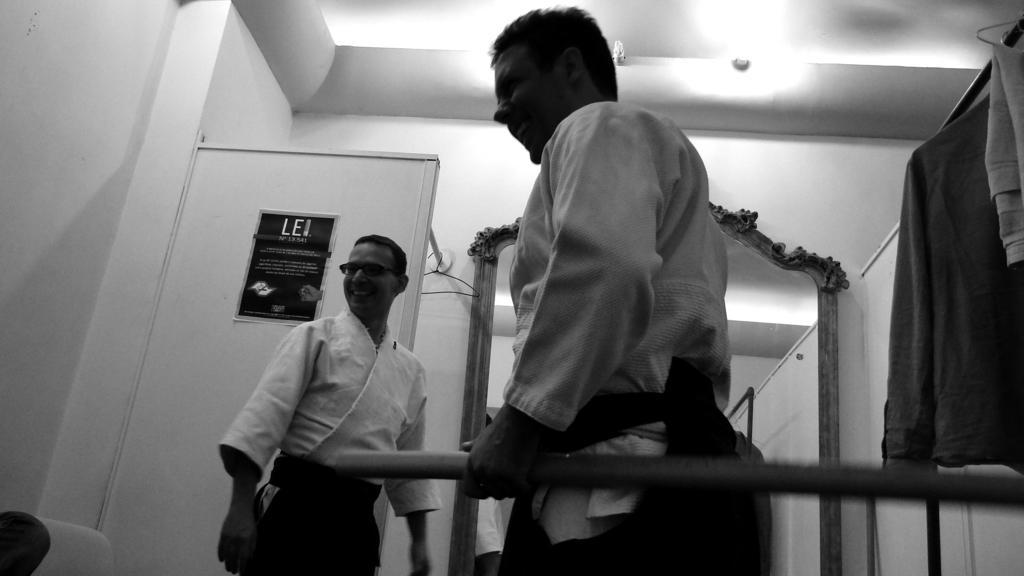Describe this image in one or two sentences. In this picture we can see a person holding a rod and smiling. We can see a man wearing a spectacle and smiling. There is some text visible on a poster. We can see this poster on a white object. There are a few rods. We can see some clothes on the hanging rods on the right side. There are lights. 